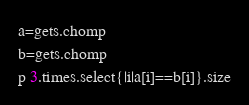<code> <loc_0><loc_0><loc_500><loc_500><_Ruby_>a=gets.chomp
b=gets.chomp
p 3.times.select{|i|a[i]==b[i]}.size
</code> 